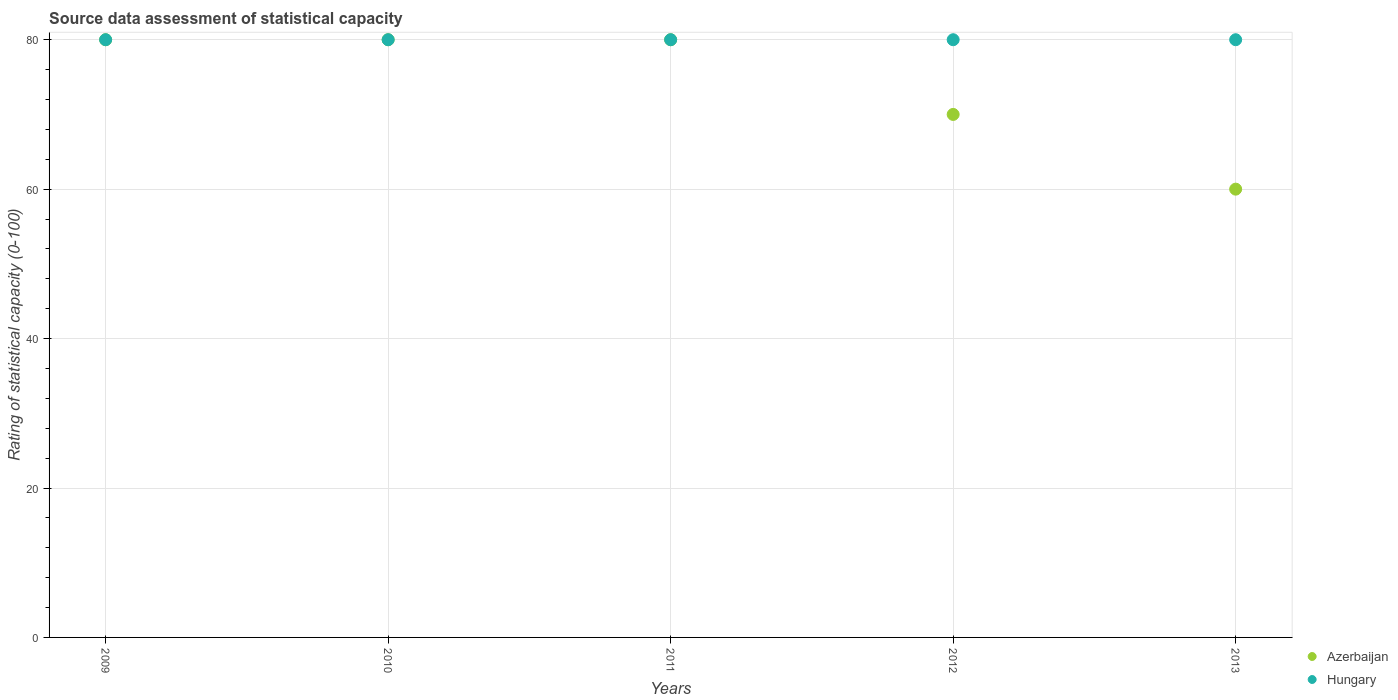What is the rating of statistical capacity in Hungary in 2009?
Keep it short and to the point. 80. Across all years, what is the maximum rating of statistical capacity in Azerbaijan?
Make the answer very short. 80. Across all years, what is the minimum rating of statistical capacity in Azerbaijan?
Your response must be concise. 60. In which year was the rating of statistical capacity in Azerbaijan maximum?
Your answer should be compact. 2009. What is the total rating of statistical capacity in Azerbaijan in the graph?
Ensure brevity in your answer.  370. What is the average rating of statistical capacity in Hungary per year?
Provide a short and direct response. 80. In the year 2011, what is the difference between the rating of statistical capacity in Hungary and rating of statistical capacity in Azerbaijan?
Provide a short and direct response. 0. Is the difference between the rating of statistical capacity in Hungary in 2009 and 2013 greater than the difference between the rating of statistical capacity in Azerbaijan in 2009 and 2013?
Make the answer very short. No. What is the difference between the highest and the second highest rating of statistical capacity in Hungary?
Ensure brevity in your answer.  0. What is the difference between the highest and the lowest rating of statistical capacity in Hungary?
Ensure brevity in your answer.  0. In how many years, is the rating of statistical capacity in Hungary greater than the average rating of statistical capacity in Hungary taken over all years?
Give a very brief answer. 0. Does the rating of statistical capacity in Azerbaijan monotonically increase over the years?
Keep it short and to the point. No. Is the rating of statistical capacity in Hungary strictly less than the rating of statistical capacity in Azerbaijan over the years?
Your answer should be compact. No. How many dotlines are there?
Provide a short and direct response. 2. How many years are there in the graph?
Provide a short and direct response. 5. What is the difference between two consecutive major ticks on the Y-axis?
Provide a succinct answer. 20. Does the graph contain grids?
Provide a succinct answer. Yes. How many legend labels are there?
Your answer should be very brief. 2. How are the legend labels stacked?
Your answer should be very brief. Vertical. What is the title of the graph?
Give a very brief answer. Source data assessment of statistical capacity. What is the label or title of the X-axis?
Give a very brief answer. Years. What is the label or title of the Y-axis?
Keep it short and to the point. Rating of statistical capacity (0-100). What is the Rating of statistical capacity (0-100) in Azerbaijan in 2009?
Provide a succinct answer. 80. What is the Rating of statistical capacity (0-100) of Hungary in 2009?
Ensure brevity in your answer.  80. What is the Rating of statistical capacity (0-100) in Hungary in 2010?
Your response must be concise. 80. What is the Rating of statistical capacity (0-100) of Hungary in 2011?
Offer a very short reply. 80. What is the Rating of statistical capacity (0-100) in Azerbaijan in 2012?
Keep it short and to the point. 70. What is the Rating of statistical capacity (0-100) in Hungary in 2012?
Your answer should be compact. 80. Across all years, what is the maximum Rating of statistical capacity (0-100) in Azerbaijan?
Provide a succinct answer. 80. What is the total Rating of statistical capacity (0-100) in Azerbaijan in the graph?
Provide a succinct answer. 370. What is the difference between the Rating of statistical capacity (0-100) of Azerbaijan in 2009 and that in 2010?
Give a very brief answer. 0. What is the difference between the Rating of statistical capacity (0-100) of Hungary in 2009 and that in 2010?
Your answer should be compact. 0. What is the difference between the Rating of statistical capacity (0-100) in Hungary in 2009 and that in 2012?
Provide a short and direct response. 0. What is the difference between the Rating of statistical capacity (0-100) of Hungary in 2009 and that in 2013?
Offer a terse response. 0. What is the difference between the Rating of statistical capacity (0-100) of Hungary in 2010 and that in 2011?
Your answer should be compact. 0. What is the difference between the Rating of statistical capacity (0-100) in Azerbaijan in 2010 and that in 2012?
Your answer should be very brief. 10. What is the difference between the Rating of statistical capacity (0-100) of Azerbaijan in 2011 and that in 2013?
Make the answer very short. 20. What is the difference between the Rating of statistical capacity (0-100) of Azerbaijan in 2012 and that in 2013?
Provide a short and direct response. 10. What is the difference between the Rating of statistical capacity (0-100) of Azerbaijan in 2009 and the Rating of statistical capacity (0-100) of Hungary in 2011?
Keep it short and to the point. 0. What is the difference between the Rating of statistical capacity (0-100) in Azerbaijan in 2009 and the Rating of statistical capacity (0-100) in Hungary in 2013?
Provide a short and direct response. 0. What is the difference between the Rating of statistical capacity (0-100) in Azerbaijan in 2010 and the Rating of statistical capacity (0-100) in Hungary in 2011?
Offer a terse response. 0. What is the difference between the Rating of statistical capacity (0-100) in Azerbaijan in 2011 and the Rating of statistical capacity (0-100) in Hungary in 2012?
Your response must be concise. 0. What is the difference between the Rating of statistical capacity (0-100) of Azerbaijan in 2011 and the Rating of statistical capacity (0-100) of Hungary in 2013?
Make the answer very short. 0. What is the difference between the Rating of statistical capacity (0-100) in Azerbaijan in 2012 and the Rating of statistical capacity (0-100) in Hungary in 2013?
Give a very brief answer. -10. What is the average Rating of statistical capacity (0-100) of Azerbaijan per year?
Your response must be concise. 74. What is the average Rating of statistical capacity (0-100) in Hungary per year?
Keep it short and to the point. 80. In the year 2009, what is the difference between the Rating of statistical capacity (0-100) of Azerbaijan and Rating of statistical capacity (0-100) of Hungary?
Your answer should be very brief. 0. In the year 2010, what is the difference between the Rating of statistical capacity (0-100) in Azerbaijan and Rating of statistical capacity (0-100) in Hungary?
Ensure brevity in your answer.  0. In the year 2011, what is the difference between the Rating of statistical capacity (0-100) in Azerbaijan and Rating of statistical capacity (0-100) in Hungary?
Your answer should be very brief. 0. In the year 2012, what is the difference between the Rating of statistical capacity (0-100) in Azerbaijan and Rating of statistical capacity (0-100) in Hungary?
Your answer should be very brief. -10. In the year 2013, what is the difference between the Rating of statistical capacity (0-100) in Azerbaijan and Rating of statistical capacity (0-100) in Hungary?
Provide a succinct answer. -20. What is the ratio of the Rating of statistical capacity (0-100) in Azerbaijan in 2009 to that in 2010?
Your answer should be compact. 1. What is the ratio of the Rating of statistical capacity (0-100) in Hungary in 2009 to that in 2011?
Offer a very short reply. 1. What is the ratio of the Rating of statistical capacity (0-100) in Hungary in 2009 to that in 2012?
Give a very brief answer. 1. What is the ratio of the Rating of statistical capacity (0-100) of Azerbaijan in 2010 to that in 2011?
Offer a terse response. 1. What is the ratio of the Rating of statistical capacity (0-100) in Hungary in 2010 to that in 2011?
Provide a short and direct response. 1. What is the ratio of the Rating of statistical capacity (0-100) in Hungary in 2010 to that in 2012?
Provide a succinct answer. 1. What is the ratio of the Rating of statistical capacity (0-100) in Azerbaijan in 2010 to that in 2013?
Ensure brevity in your answer.  1.33. What is the ratio of the Rating of statistical capacity (0-100) of Hungary in 2011 to that in 2012?
Keep it short and to the point. 1. What is the ratio of the Rating of statistical capacity (0-100) in Azerbaijan in 2011 to that in 2013?
Provide a succinct answer. 1.33. What is the ratio of the Rating of statistical capacity (0-100) of Hungary in 2011 to that in 2013?
Provide a succinct answer. 1. What is the ratio of the Rating of statistical capacity (0-100) in Hungary in 2012 to that in 2013?
Your answer should be very brief. 1. What is the difference between the highest and the lowest Rating of statistical capacity (0-100) in Azerbaijan?
Your answer should be compact. 20. 